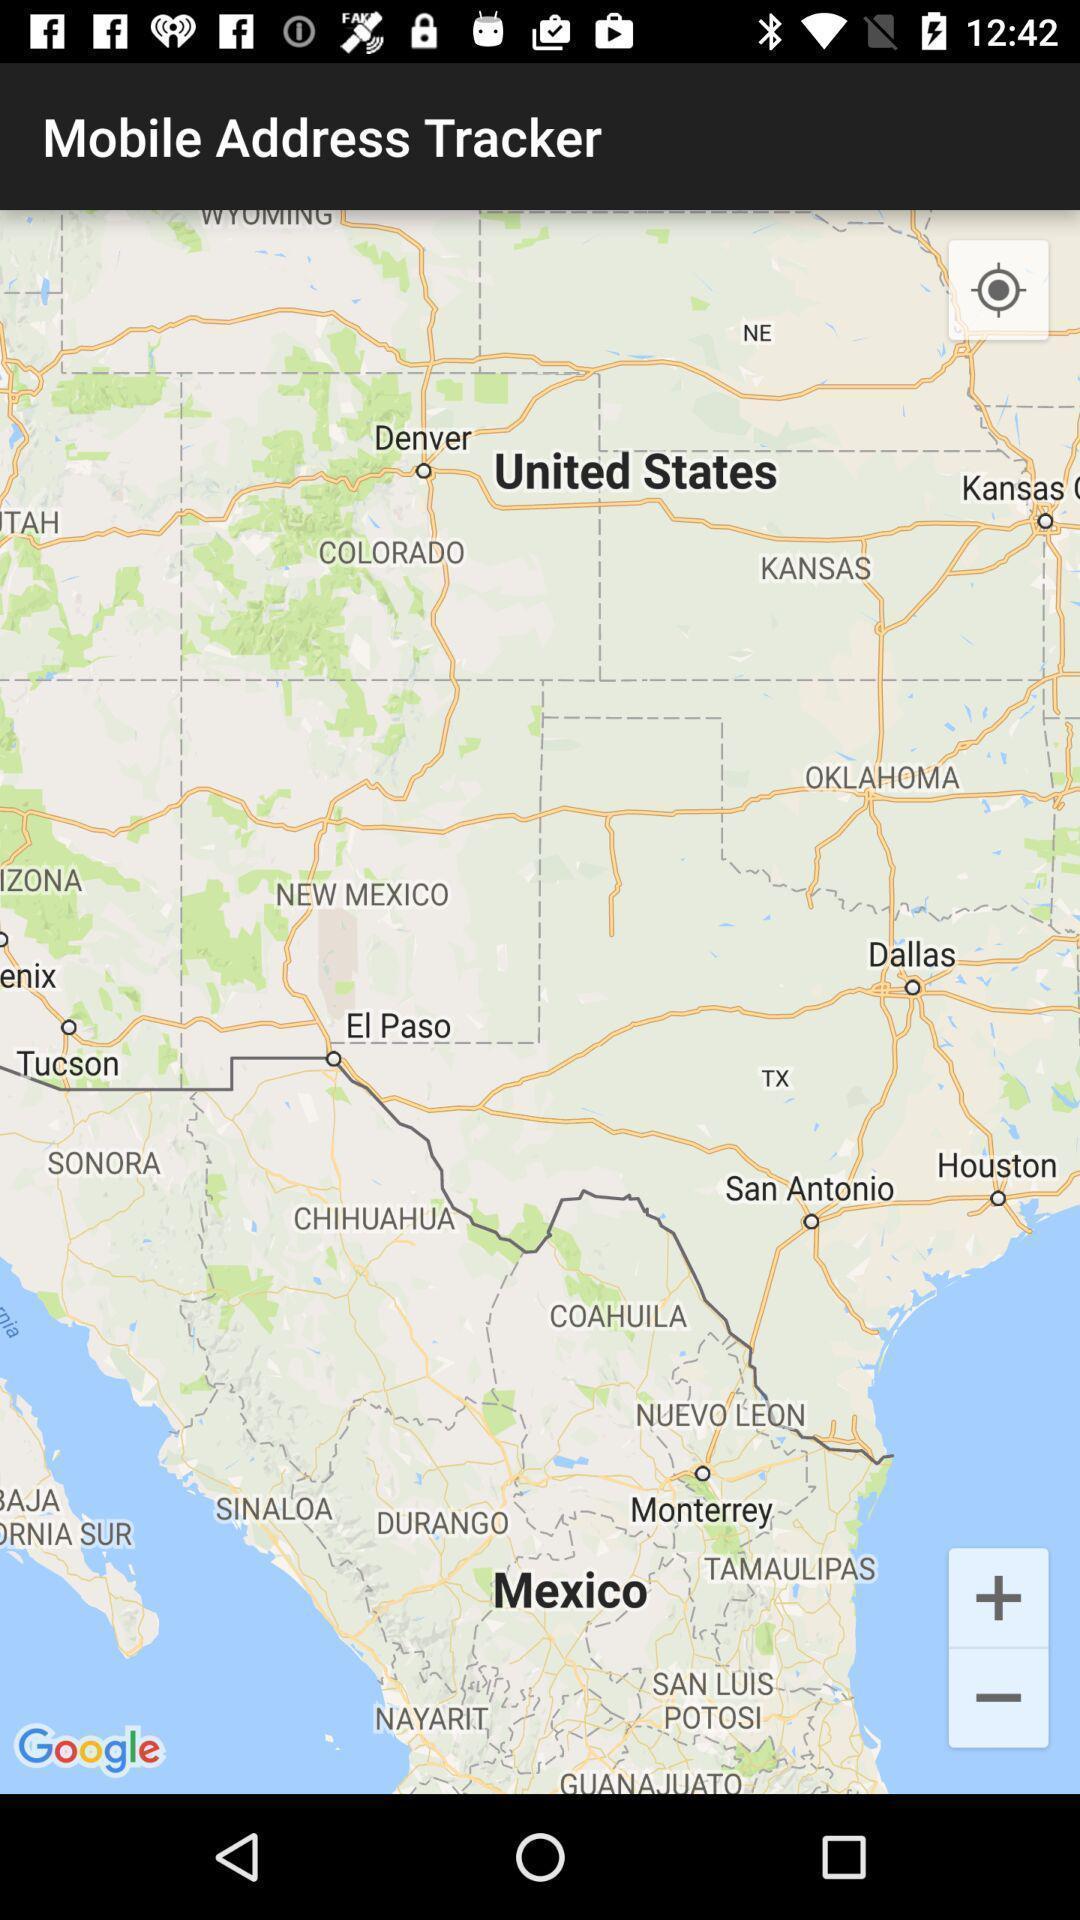Provide a detailed account of this screenshot. Page displaying the world map. 